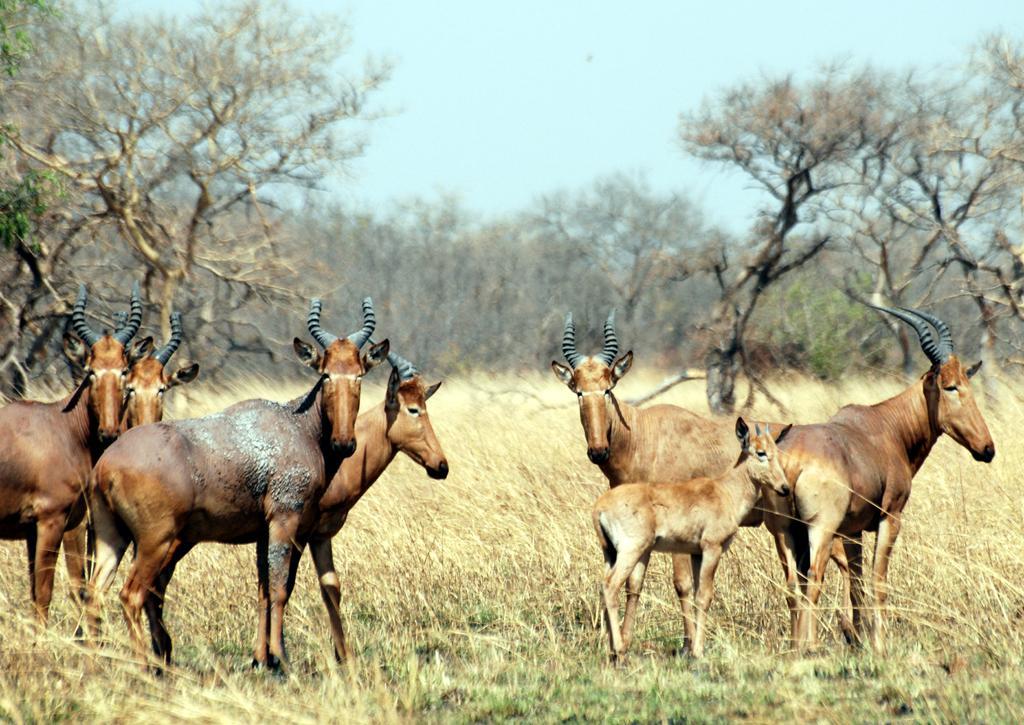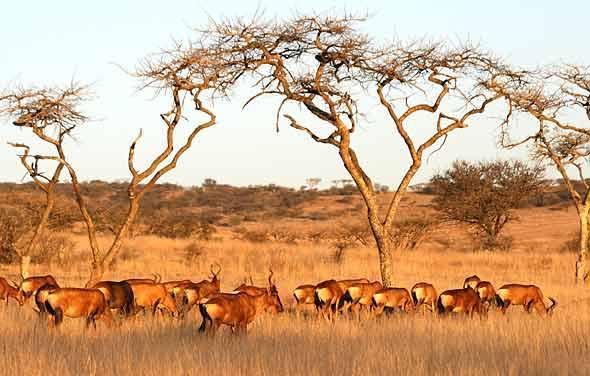The first image is the image on the left, the second image is the image on the right. Examine the images to the left and right. Is the description "At least one photo has two or fewer animals." accurate? Answer yes or no. No. The first image is the image on the left, the second image is the image on the right. For the images displayed, is the sentence "In one image, none of the horned animals are standing on the ground." factually correct? Answer yes or no. No. 